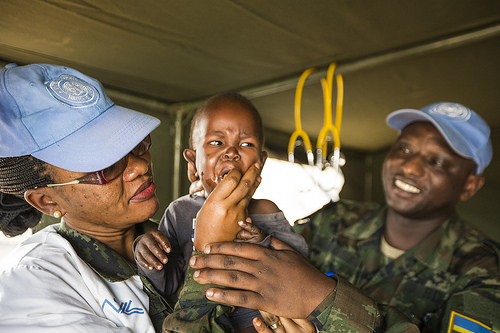<image>
Is the baby on the man? No. The baby is not positioned on the man. They may be near each other, but the baby is not supported by or resting on top of the man. Is the mom to the right of the baby? Yes. From this viewpoint, the mom is positioned to the right side relative to the baby. Where is the cap in relation to the bus? Is it next to the bus? No. The cap is not positioned next to the bus. They are located in different areas of the scene. 